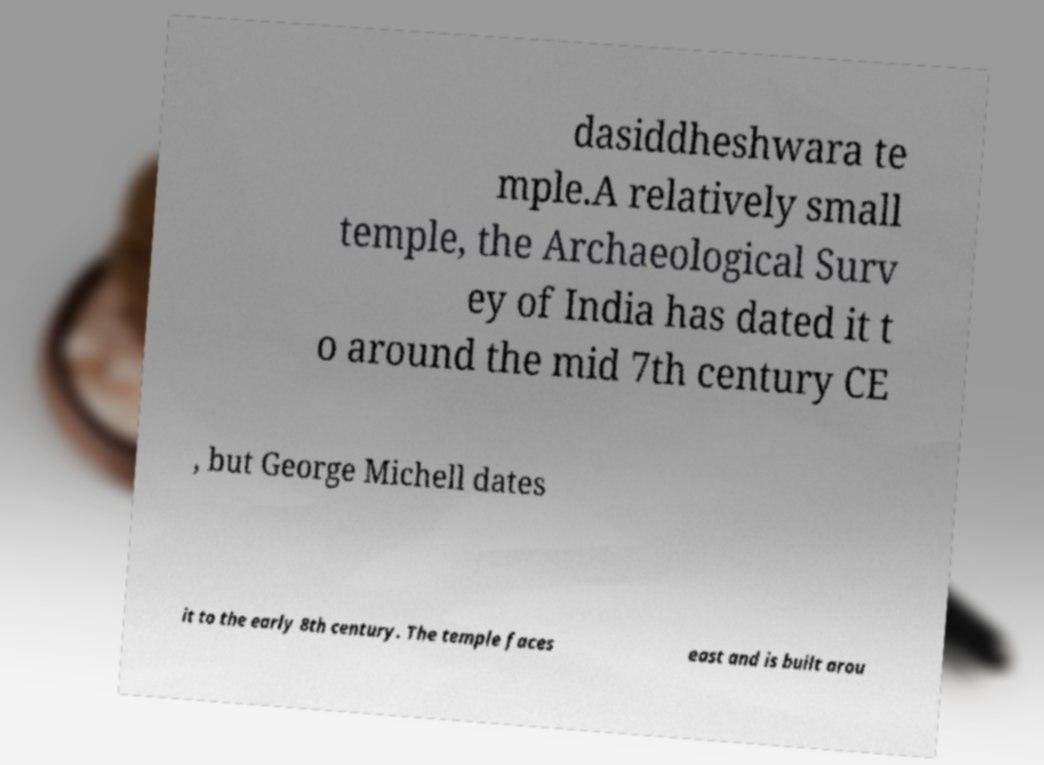Please read and relay the text visible in this image. What does it say? dasiddheshwara te mple.A relatively small temple, the Archaeological Surv ey of India has dated it t o around the mid 7th century CE , but George Michell dates it to the early 8th century. The temple faces east and is built arou 